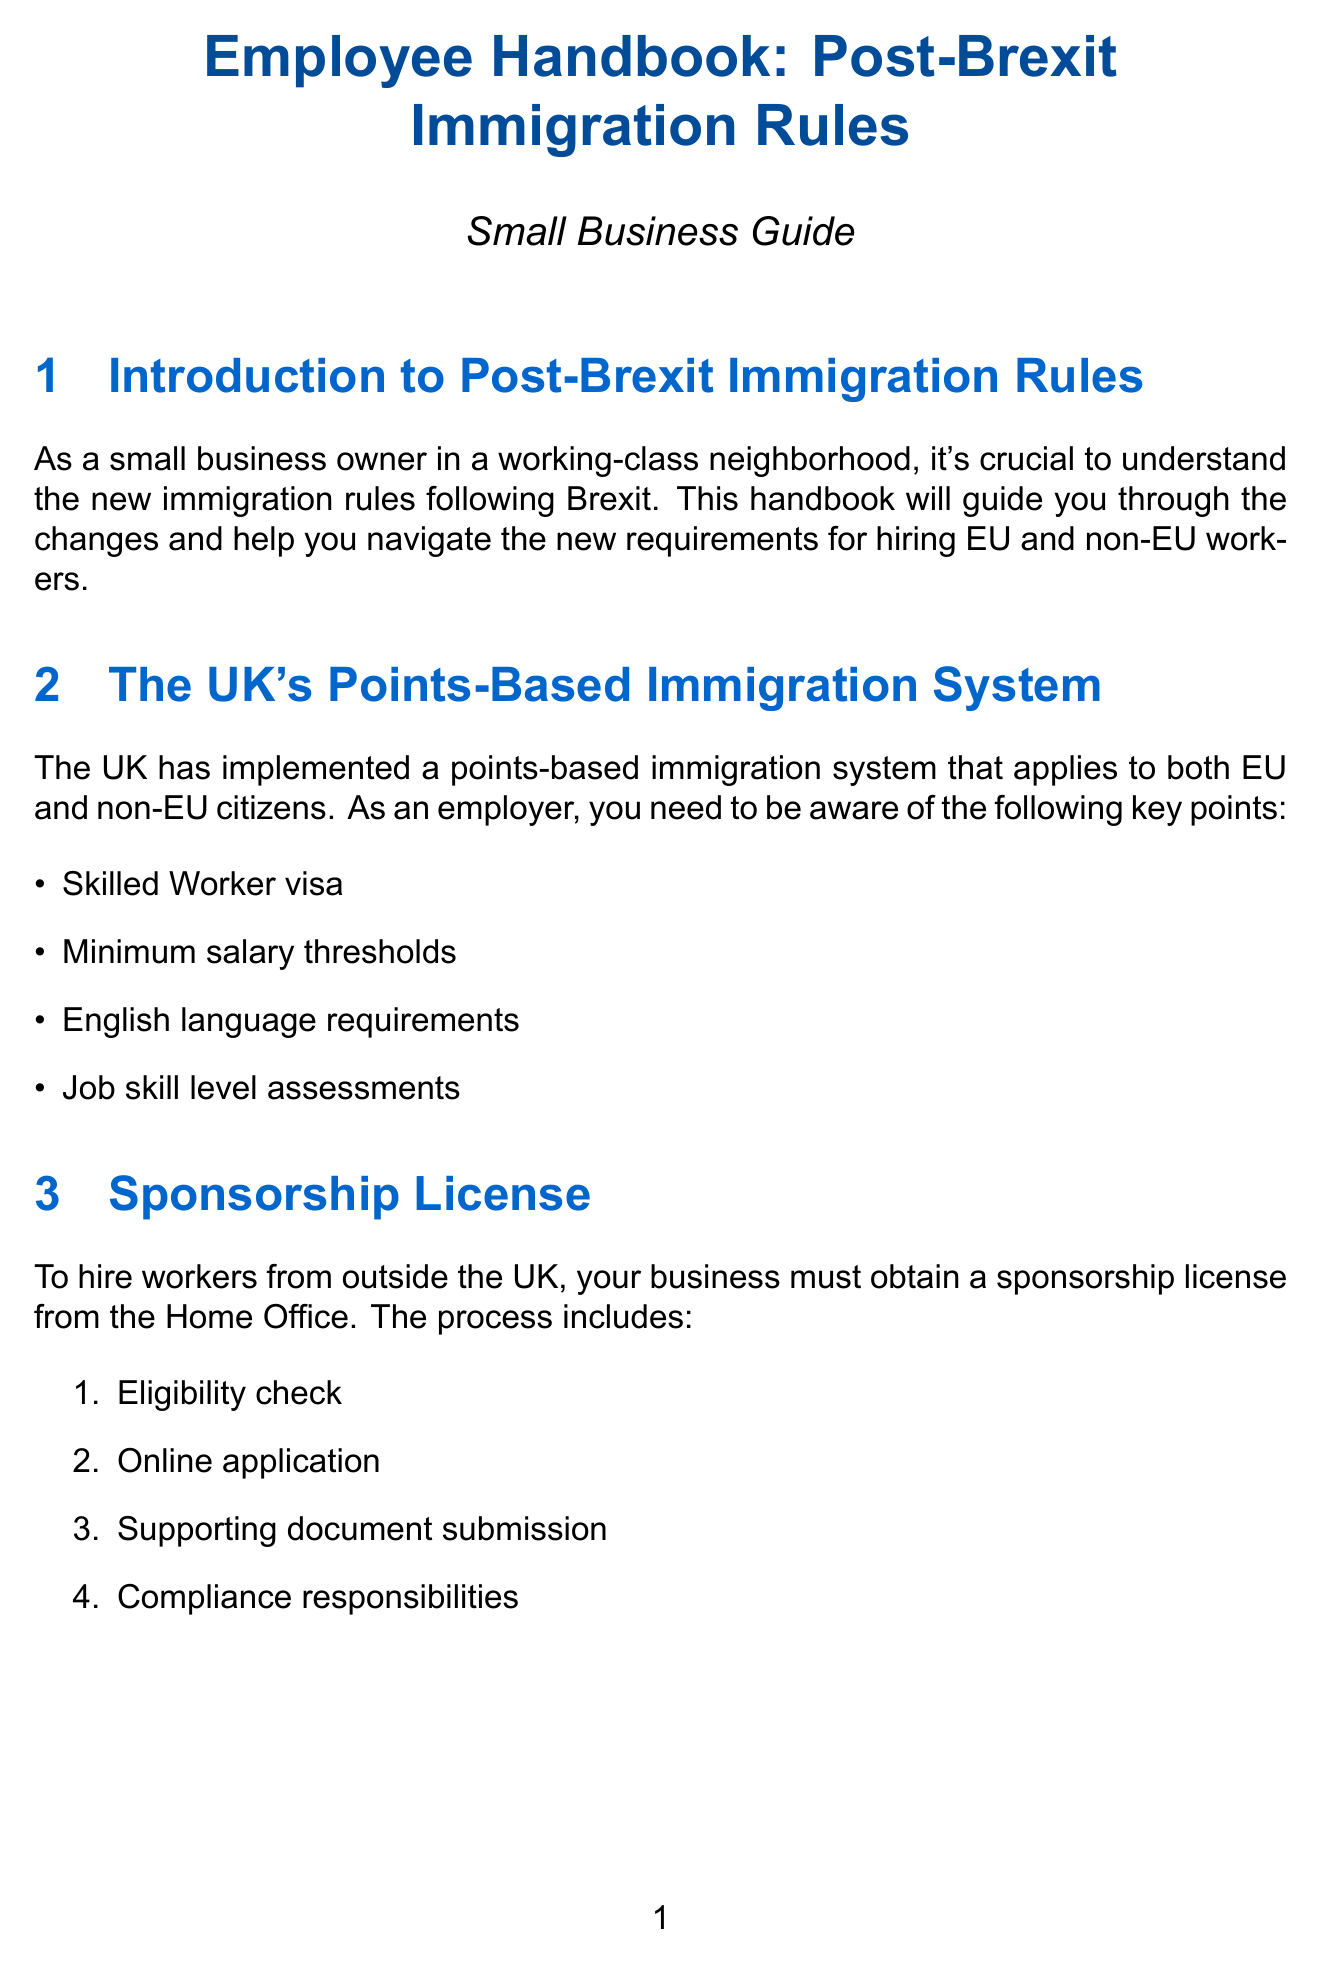What is the points-based immigration system? The points-based immigration system that applies to both EU and non-EU citizens involves criteria such as skilled worker visa, minimum salary thresholds, English language requirements, and job skill level assessments.
Answer: Points-based immigration system What must a business obtain to hire workers from outside the UK? A business must obtain a sponsorship license from the Home Office.
Answer: Sponsorship license What are right to work checks for? Right to work checks are required for all employees, regardless of their nationality, to ensure they have the legal right to work in the UK.
Answer: Legal right to work Who can apply to the EU Settlement Scheme? EU, EEA, and Swiss citizens who were living in the UK before 31 December 2020 can apply to the EU Settlement Scheme.
Answer: EU, EEA, and Swiss citizens How many types of work permits and visas are listed in the document? The document lists four types of work permits and visas.
Answer: Four What are some local resources available for small business owners? Local Enterprise Partnerships, Chambers of Commerce, Federation of Small Businesses, and UK Visas and Immigration helpline are available local resources.
Answer: Local Enterprise Partnerships, Chambers of Commerce, Federation of Small Businesses, UKVI helpline What is the immigration skills charge? The immigration skills charge is a fee that employers must pay when hiring non-UK workers.
Answer: Immigration Skills Charge What should businesses do to avoid penalties? Businesses should keep up-to-date employee records and maintain copies of relevant documents to avoid penalties.
Answer: Keep up-to-date employee records and maintain copies of relevant documents 